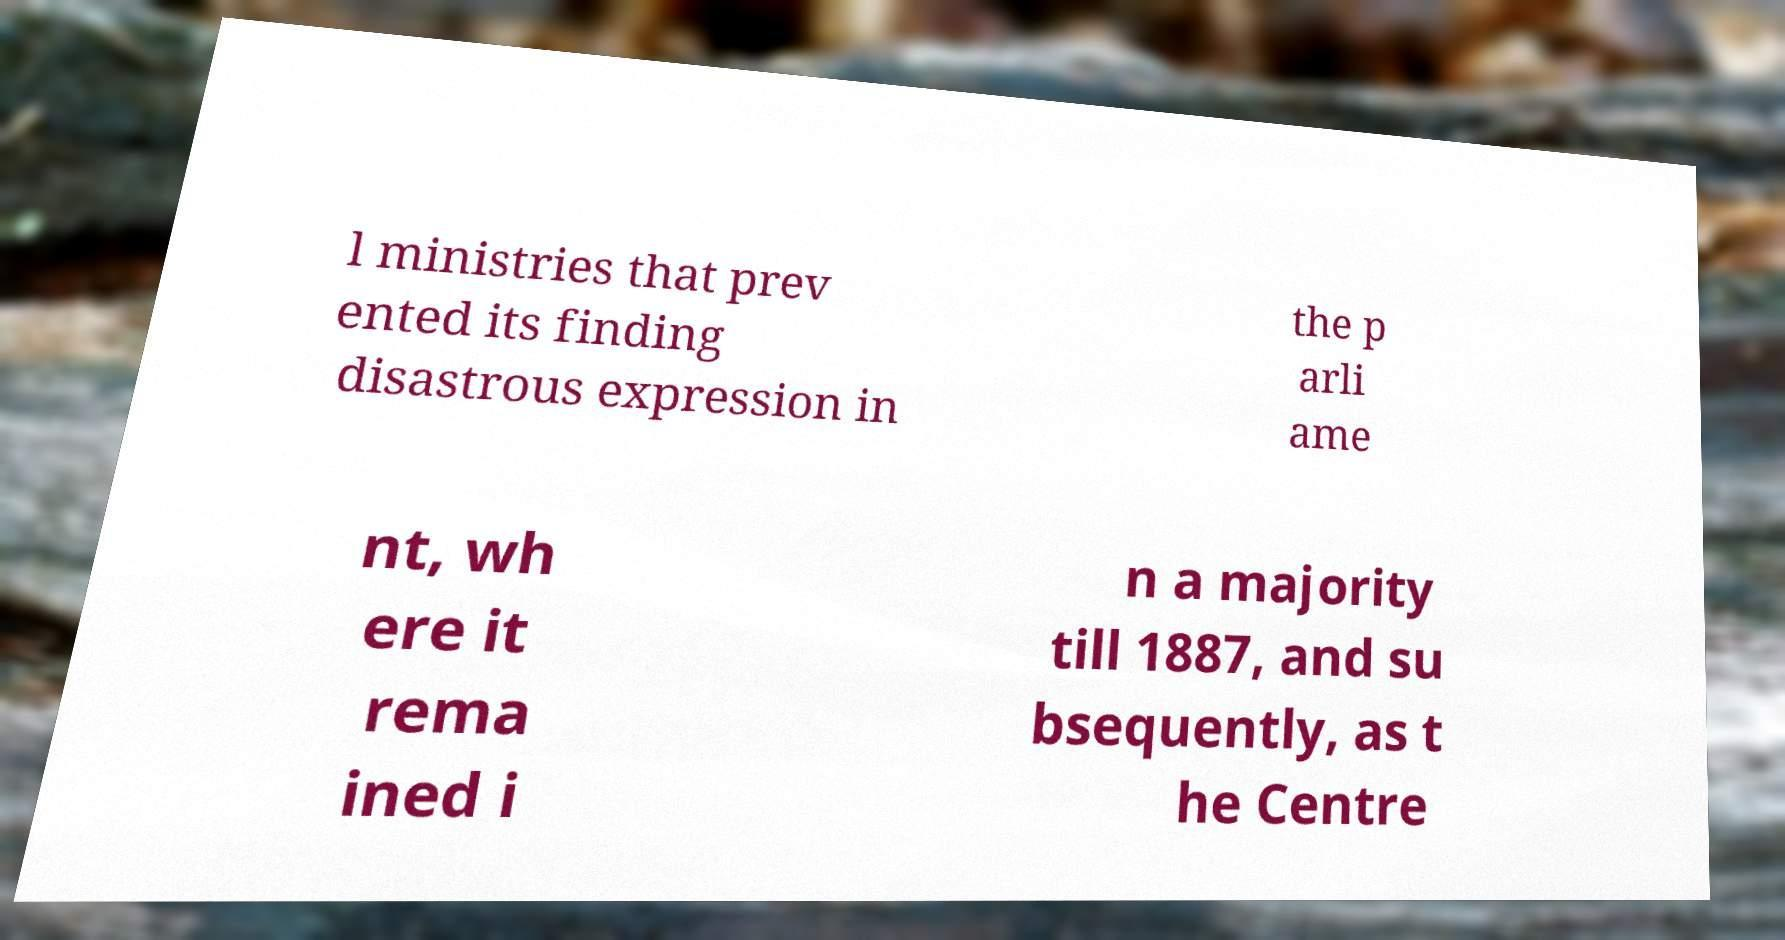Please identify and transcribe the text found in this image. l ministries that prev ented its finding disastrous expression in the p arli ame nt, wh ere it rema ined i n a majority till 1887, and su bsequently, as t he Centre 